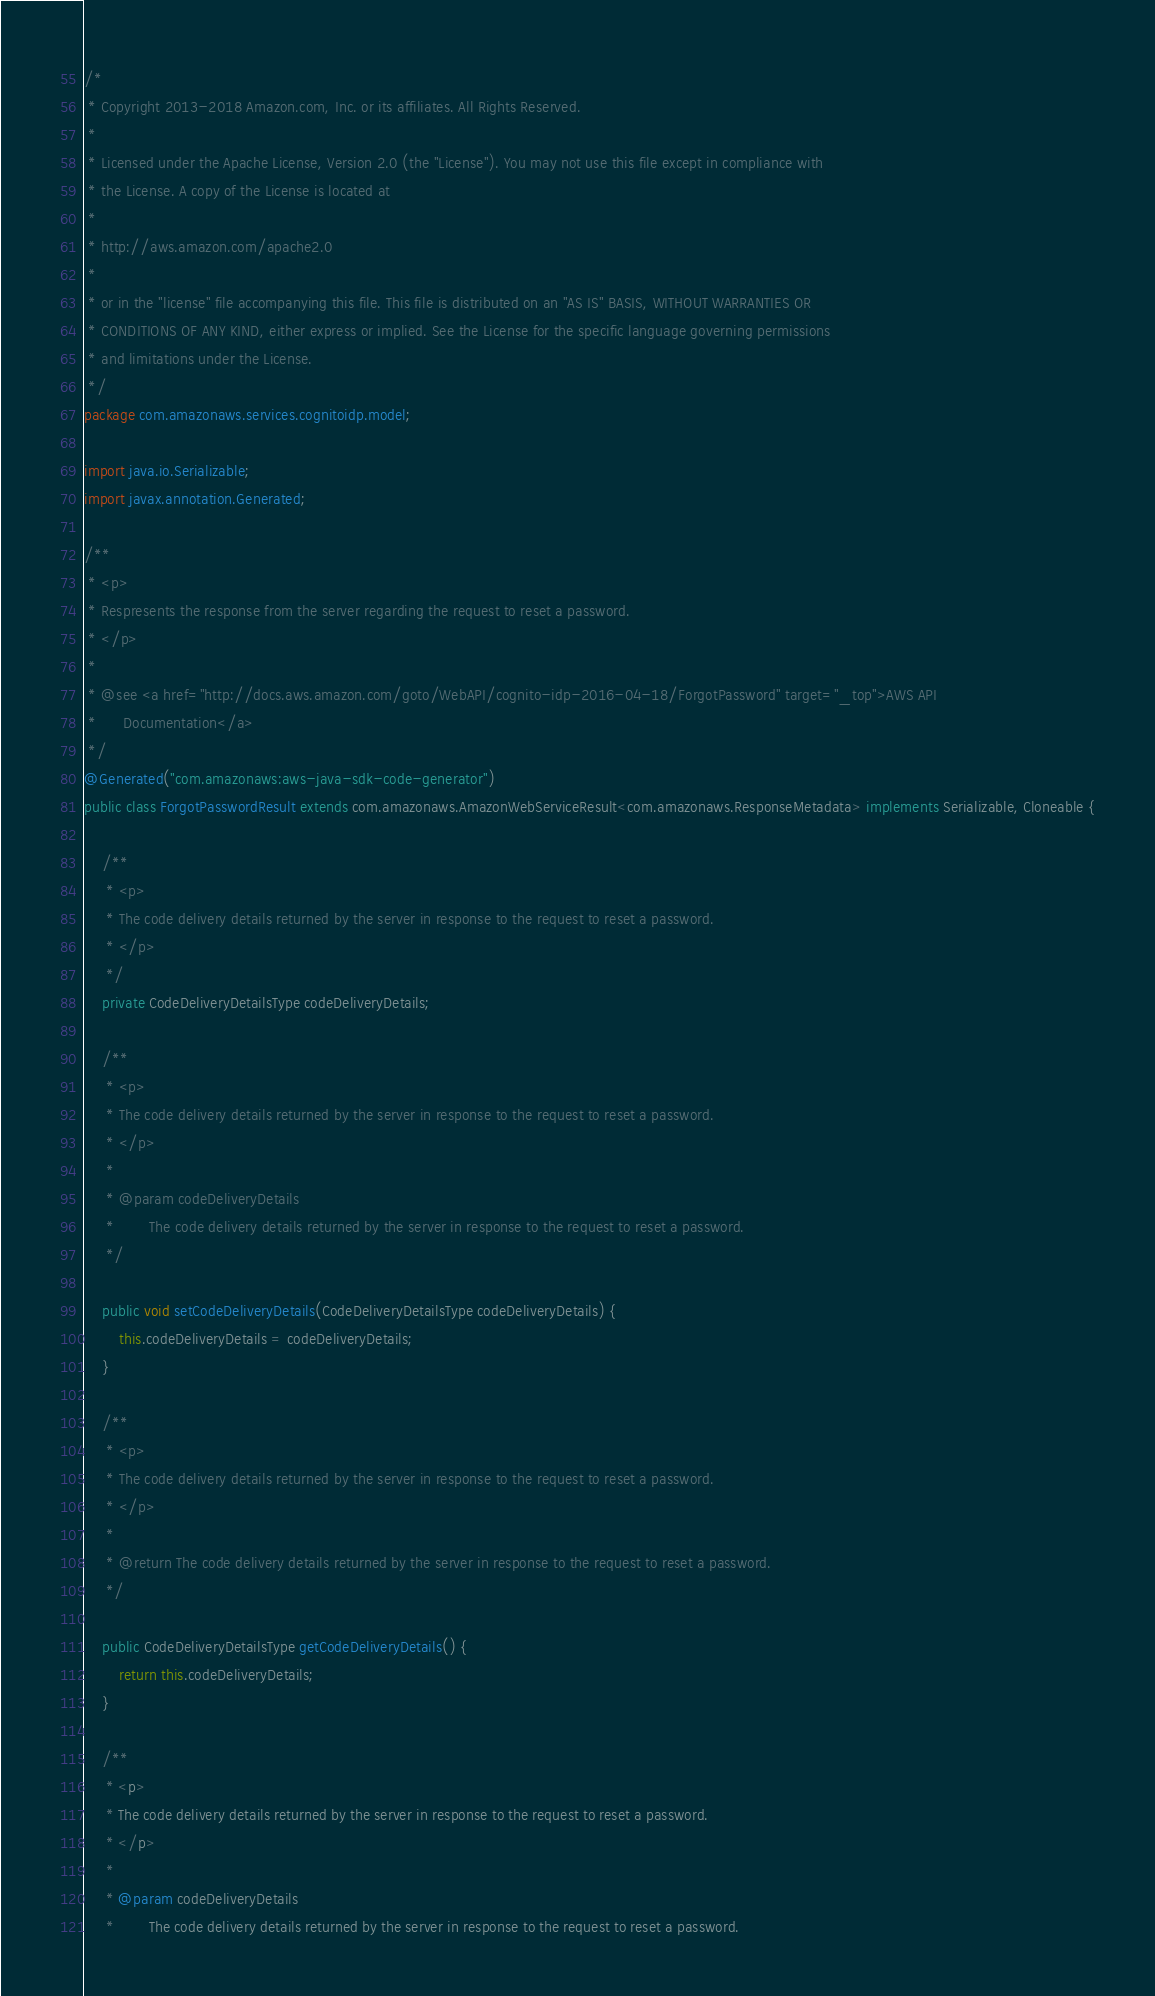Convert code to text. <code><loc_0><loc_0><loc_500><loc_500><_Java_>/*
 * Copyright 2013-2018 Amazon.com, Inc. or its affiliates. All Rights Reserved.
 * 
 * Licensed under the Apache License, Version 2.0 (the "License"). You may not use this file except in compliance with
 * the License. A copy of the License is located at
 * 
 * http://aws.amazon.com/apache2.0
 * 
 * or in the "license" file accompanying this file. This file is distributed on an "AS IS" BASIS, WITHOUT WARRANTIES OR
 * CONDITIONS OF ANY KIND, either express or implied. See the License for the specific language governing permissions
 * and limitations under the License.
 */
package com.amazonaws.services.cognitoidp.model;

import java.io.Serializable;
import javax.annotation.Generated;

/**
 * <p>
 * Respresents the response from the server regarding the request to reset a password.
 * </p>
 * 
 * @see <a href="http://docs.aws.amazon.com/goto/WebAPI/cognito-idp-2016-04-18/ForgotPassword" target="_top">AWS API
 *      Documentation</a>
 */
@Generated("com.amazonaws:aws-java-sdk-code-generator")
public class ForgotPasswordResult extends com.amazonaws.AmazonWebServiceResult<com.amazonaws.ResponseMetadata> implements Serializable, Cloneable {

    /**
     * <p>
     * The code delivery details returned by the server in response to the request to reset a password.
     * </p>
     */
    private CodeDeliveryDetailsType codeDeliveryDetails;

    /**
     * <p>
     * The code delivery details returned by the server in response to the request to reset a password.
     * </p>
     * 
     * @param codeDeliveryDetails
     *        The code delivery details returned by the server in response to the request to reset a password.
     */

    public void setCodeDeliveryDetails(CodeDeliveryDetailsType codeDeliveryDetails) {
        this.codeDeliveryDetails = codeDeliveryDetails;
    }

    /**
     * <p>
     * The code delivery details returned by the server in response to the request to reset a password.
     * </p>
     * 
     * @return The code delivery details returned by the server in response to the request to reset a password.
     */

    public CodeDeliveryDetailsType getCodeDeliveryDetails() {
        return this.codeDeliveryDetails;
    }

    /**
     * <p>
     * The code delivery details returned by the server in response to the request to reset a password.
     * </p>
     * 
     * @param codeDeliveryDetails
     *        The code delivery details returned by the server in response to the request to reset a password.</code> 